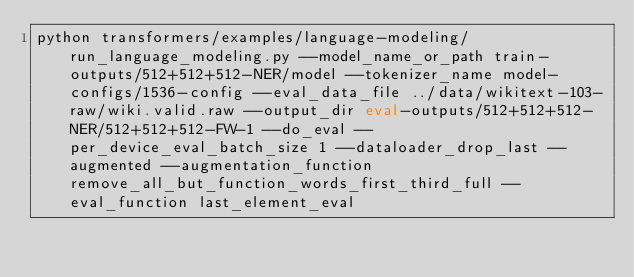<code> <loc_0><loc_0><loc_500><loc_500><_Bash_>python transformers/examples/language-modeling/run_language_modeling.py --model_name_or_path train-outputs/512+512+512-NER/model --tokenizer_name model-configs/1536-config --eval_data_file ../data/wikitext-103-raw/wiki.valid.raw --output_dir eval-outputs/512+512+512-NER/512+512+512-FW-1 --do_eval --per_device_eval_batch_size 1 --dataloader_drop_last --augmented --augmentation_function remove_all_but_function_words_first_third_full --eval_function last_element_eval</code> 